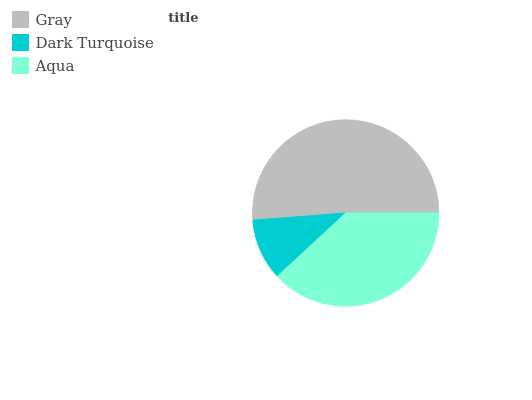Is Dark Turquoise the minimum?
Answer yes or no. Yes. Is Gray the maximum?
Answer yes or no. Yes. Is Aqua the minimum?
Answer yes or no. No. Is Aqua the maximum?
Answer yes or no. No. Is Aqua greater than Dark Turquoise?
Answer yes or no. Yes. Is Dark Turquoise less than Aqua?
Answer yes or no. Yes. Is Dark Turquoise greater than Aqua?
Answer yes or no. No. Is Aqua less than Dark Turquoise?
Answer yes or no. No. Is Aqua the high median?
Answer yes or no. Yes. Is Aqua the low median?
Answer yes or no. Yes. Is Dark Turquoise the high median?
Answer yes or no. No. Is Gray the low median?
Answer yes or no. No. 